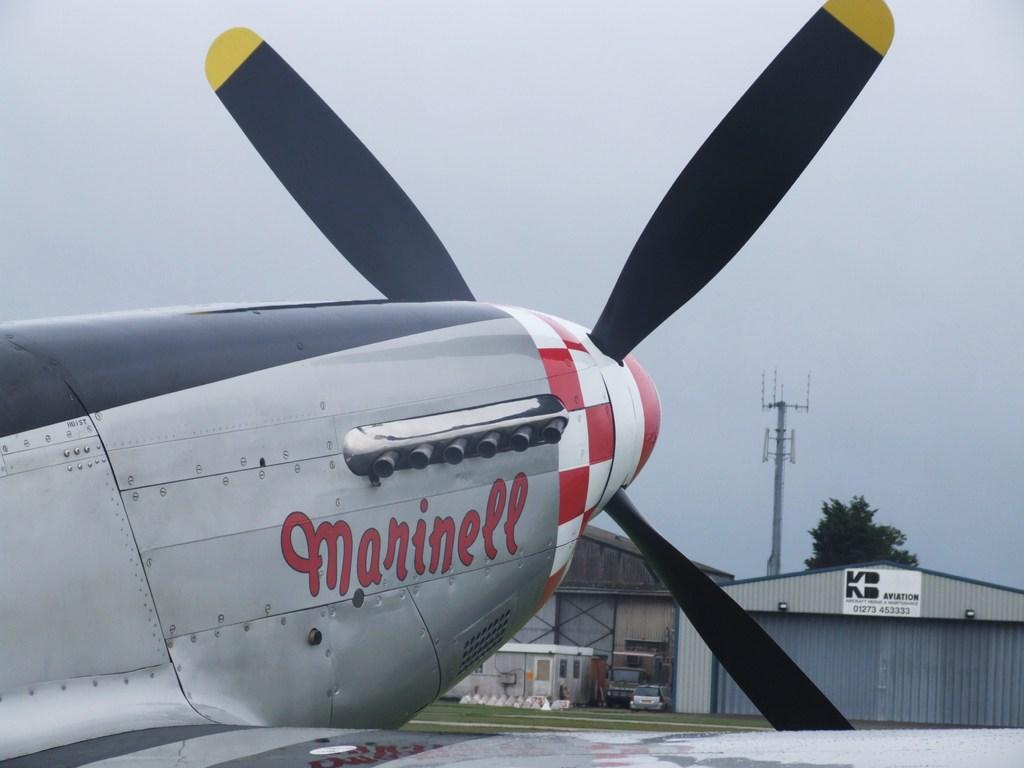What is the main subject in the middle of the image? There is a plane in the middle of the image. What can be seen behind the plane? There are sheds, vehicles, poles, and trees behind the plane. What type of terrain is visible in the image? Grass is visible in the image. What is visible at the top of the image? The sky is visible at the top of the image. What type of song is being played by the plane in the image? There is no indication in the image that the plane is playing a song, so it cannot be determined from the picture. 